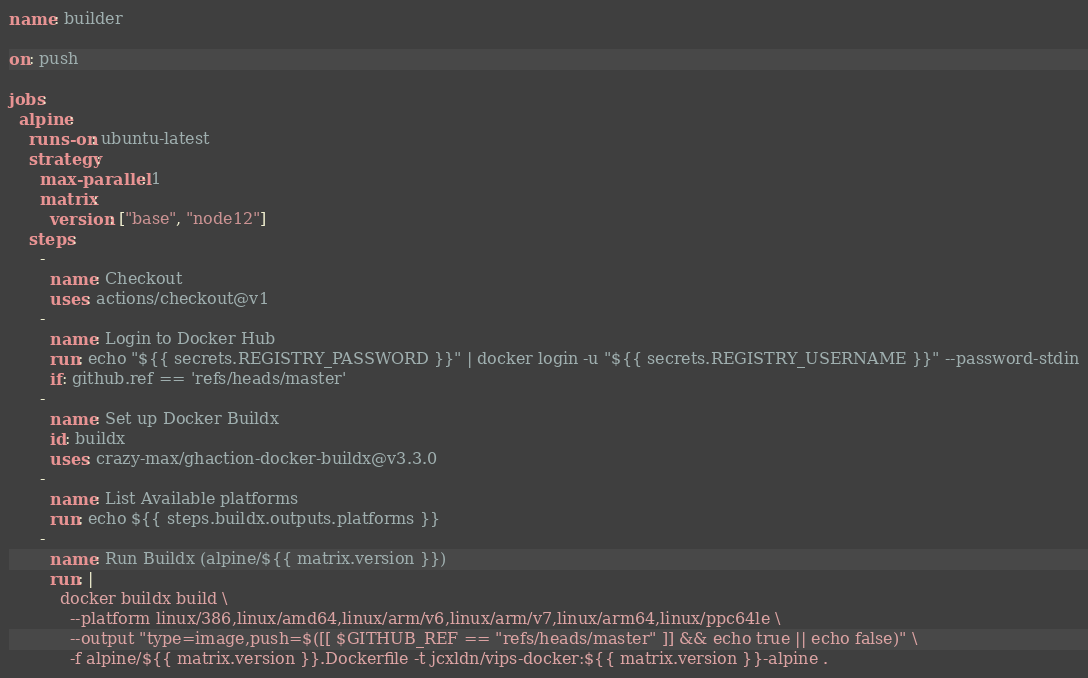Convert code to text. <code><loc_0><loc_0><loc_500><loc_500><_YAML_>name: builder

on: push

jobs:
  alpine:
    runs-on: ubuntu-latest
    strategy:
      max-parallel: 1
      matrix:
        version: ["base", "node12"]
    steps:
      -
        name: Checkout
        uses: actions/checkout@v1
      -
        name: Login to Docker Hub
        run: echo "${{ secrets.REGISTRY_PASSWORD }}" | docker login -u "${{ secrets.REGISTRY_USERNAME }}" --password-stdin
        if: github.ref == 'refs/heads/master'
      - 
        name: Set up Docker Buildx
        id: buildx
        uses: crazy-max/ghaction-docker-buildx@v3.3.0
      -
        name: List Available platforms
        run: echo ${{ steps.buildx.outputs.platforms }}
      -
        name: Run Buildx (alpine/${{ matrix.version }})
        run: |
          docker buildx build \
            --platform linux/386,linux/amd64,linux/arm/v6,linux/arm/v7,linux/arm64,linux/ppc64le \
            --output "type=image,push=$([[ $GITHUB_REF == "refs/heads/master" ]] && echo true || echo false)" \
            -f alpine/${{ matrix.version }}.Dockerfile -t jcxldn/vips-docker:${{ matrix.version }}-alpine .
</code> 